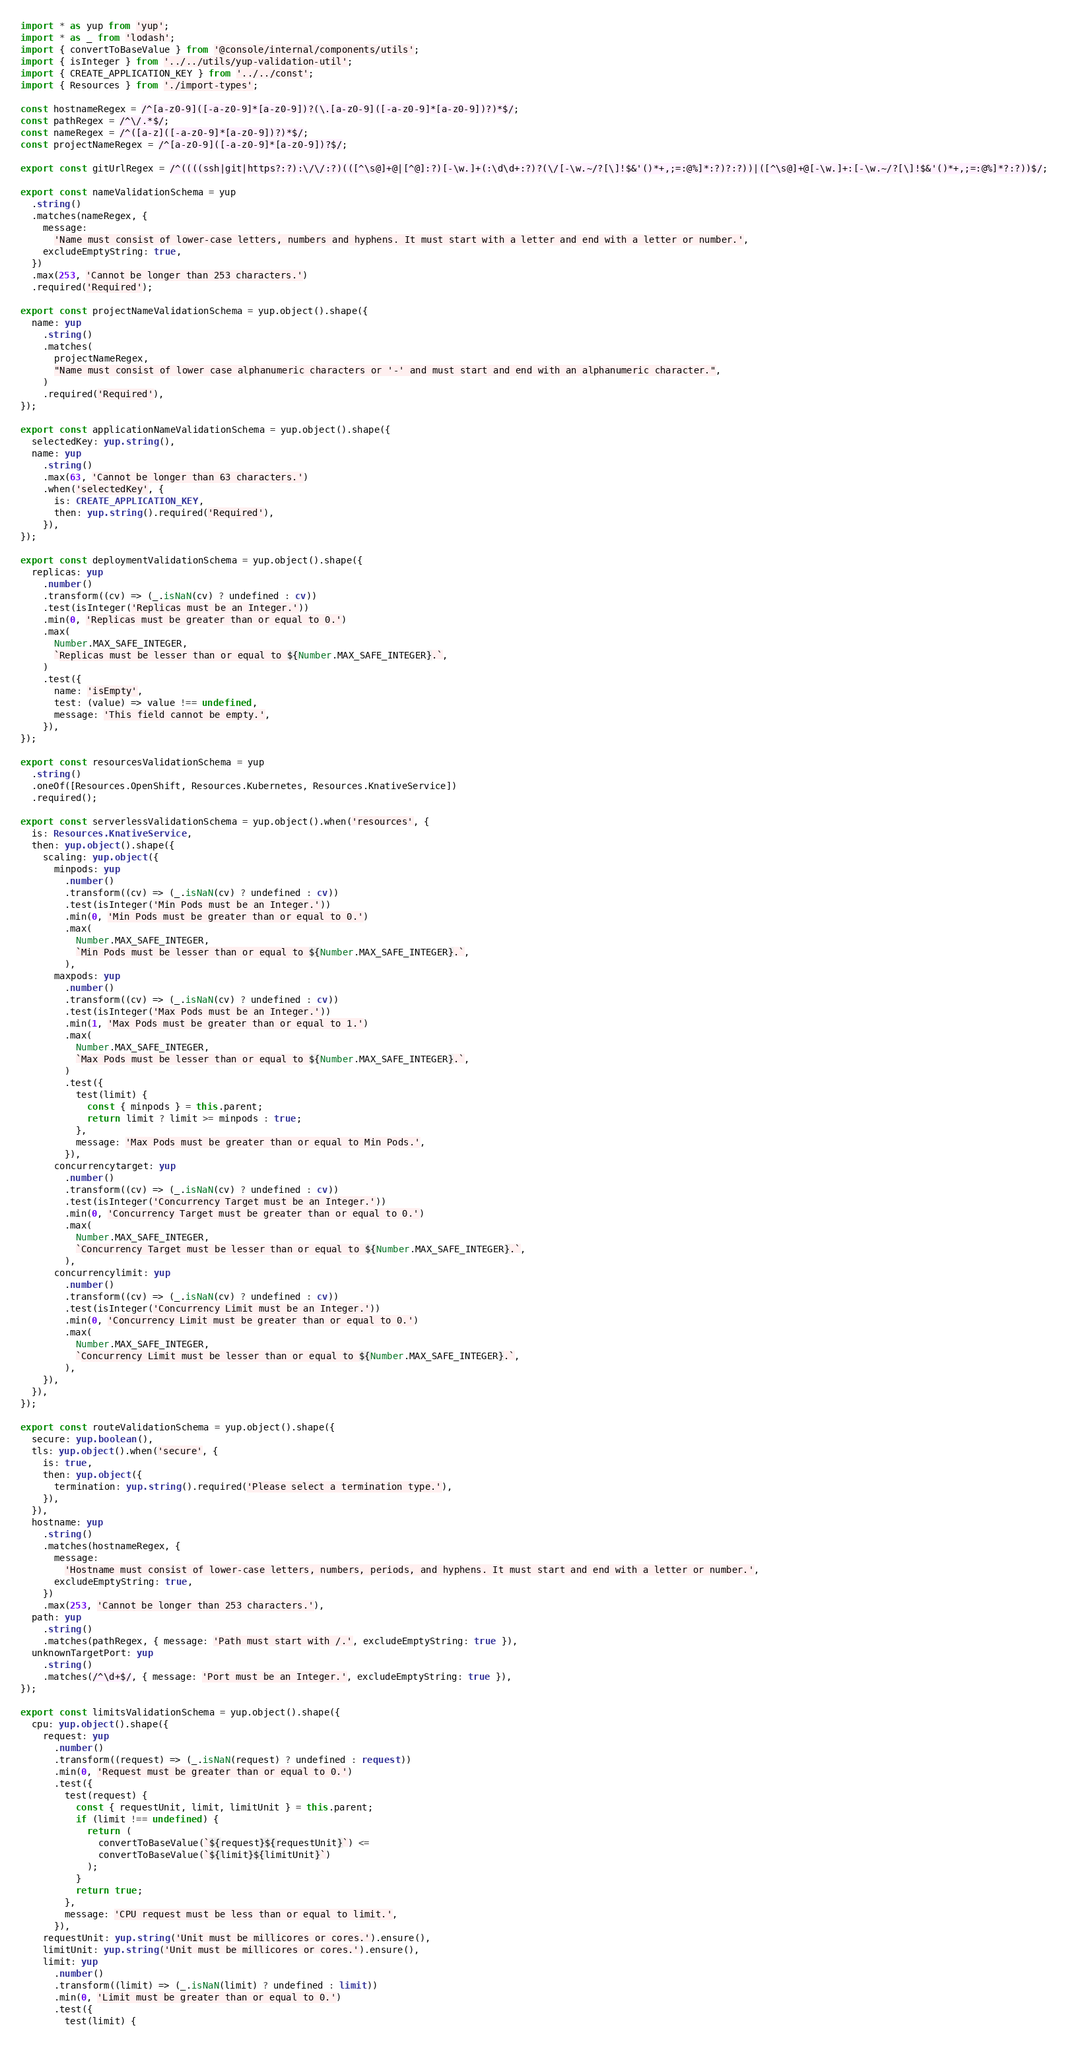<code> <loc_0><loc_0><loc_500><loc_500><_TypeScript_>import * as yup from 'yup';
import * as _ from 'lodash';
import { convertToBaseValue } from '@console/internal/components/utils';
import { isInteger } from '../../utils/yup-validation-util';
import { CREATE_APPLICATION_KEY } from '../../const';
import { Resources } from './import-types';

const hostnameRegex = /^[a-z0-9]([-a-z0-9]*[a-z0-9])?(\.[a-z0-9]([-a-z0-9]*[a-z0-9])?)*$/;
const pathRegex = /^\/.*$/;
const nameRegex = /^([a-z]([-a-z0-9]*[a-z0-9])?)*$/;
const projectNameRegex = /^[a-z0-9]([-a-z0-9]*[a-z0-9])?$/;

export const gitUrlRegex = /^((((ssh|git|https?:?):\/\/:?)(([^\s@]+@|[^@]:?)[-\w.]+(:\d\d+:?)?(\/[-\w.~/?[\]!$&'()*+,;=:@%]*:?)?:?))|([^\s@]+@[-\w.]+:[-\w.~/?[\]!$&'()*+,;=:@%]*?:?))$/;

export const nameValidationSchema = yup
  .string()
  .matches(nameRegex, {
    message:
      'Name must consist of lower-case letters, numbers and hyphens. It must start with a letter and end with a letter or number.',
    excludeEmptyString: true,
  })
  .max(253, 'Cannot be longer than 253 characters.')
  .required('Required');

export const projectNameValidationSchema = yup.object().shape({
  name: yup
    .string()
    .matches(
      projectNameRegex,
      "Name must consist of lower case alphanumeric characters or '-' and must start and end with an alphanumeric character.",
    )
    .required('Required'),
});

export const applicationNameValidationSchema = yup.object().shape({
  selectedKey: yup.string(),
  name: yup
    .string()
    .max(63, 'Cannot be longer than 63 characters.')
    .when('selectedKey', {
      is: CREATE_APPLICATION_KEY,
      then: yup.string().required('Required'),
    }),
});

export const deploymentValidationSchema = yup.object().shape({
  replicas: yup
    .number()
    .transform((cv) => (_.isNaN(cv) ? undefined : cv))
    .test(isInteger('Replicas must be an Integer.'))
    .min(0, 'Replicas must be greater than or equal to 0.')
    .max(
      Number.MAX_SAFE_INTEGER,
      `Replicas must be lesser than or equal to ${Number.MAX_SAFE_INTEGER}.`,
    )
    .test({
      name: 'isEmpty',
      test: (value) => value !== undefined,
      message: 'This field cannot be empty.',
    }),
});

export const resourcesValidationSchema = yup
  .string()
  .oneOf([Resources.OpenShift, Resources.Kubernetes, Resources.KnativeService])
  .required();

export const serverlessValidationSchema = yup.object().when('resources', {
  is: Resources.KnativeService,
  then: yup.object().shape({
    scaling: yup.object({
      minpods: yup
        .number()
        .transform((cv) => (_.isNaN(cv) ? undefined : cv))
        .test(isInteger('Min Pods must be an Integer.'))
        .min(0, 'Min Pods must be greater than or equal to 0.')
        .max(
          Number.MAX_SAFE_INTEGER,
          `Min Pods must be lesser than or equal to ${Number.MAX_SAFE_INTEGER}.`,
        ),
      maxpods: yup
        .number()
        .transform((cv) => (_.isNaN(cv) ? undefined : cv))
        .test(isInteger('Max Pods must be an Integer.'))
        .min(1, 'Max Pods must be greater than or equal to 1.')
        .max(
          Number.MAX_SAFE_INTEGER,
          `Max Pods must be lesser than or equal to ${Number.MAX_SAFE_INTEGER}.`,
        )
        .test({
          test(limit) {
            const { minpods } = this.parent;
            return limit ? limit >= minpods : true;
          },
          message: 'Max Pods must be greater than or equal to Min Pods.',
        }),
      concurrencytarget: yup
        .number()
        .transform((cv) => (_.isNaN(cv) ? undefined : cv))
        .test(isInteger('Concurrency Target must be an Integer.'))
        .min(0, 'Concurrency Target must be greater than or equal to 0.')
        .max(
          Number.MAX_SAFE_INTEGER,
          `Concurrency Target must be lesser than or equal to ${Number.MAX_SAFE_INTEGER}.`,
        ),
      concurrencylimit: yup
        .number()
        .transform((cv) => (_.isNaN(cv) ? undefined : cv))
        .test(isInteger('Concurrency Limit must be an Integer.'))
        .min(0, 'Concurrency Limit must be greater than or equal to 0.')
        .max(
          Number.MAX_SAFE_INTEGER,
          `Concurrency Limit must be lesser than or equal to ${Number.MAX_SAFE_INTEGER}.`,
        ),
    }),
  }),
});

export const routeValidationSchema = yup.object().shape({
  secure: yup.boolean(),
  tls: yup.object().when('secure', {
    is: true,
    then: yup.object({
      termination: yup.string().required('Please select a termination type.'),
    }),
  }),
  hostname: yup
    .string()
    .matches(hostnameRegex, {
      message:
        'Hostname must consist of lower-case letters, numbers, periods, and hyphens. It must start and end with a letter or number.',
      excludeEmptyString: true,
    })
    .max(253, 'Cannot be longer than 253 characters.'),
  path: yup
    .string()
    .matches(pathRegex, { message: 'Path must start with /.', excludeEmptyString: true }),
  unknownTargetPort: yup
    .string()
    .matches(/^\d+$/, { message: 'Port must be an Integer.', excludeEmptyString: true }),
});

export const limitsValidationSchema = yup.object().shape({
  cpu: yup.object().shape({
    request: yup
      .number()
      .transform((request) => (_.isNaN(request) ? undefined : request))
      .min(0, 'Request must be greater than or equal to 0.')
      .test({
        test(request) {
          const { requestUnit, limit, limitUnit } = this.parent;
          if (limit !== undefined) {
            return (
              convertToBaseValue(`${request}${requestUnit}`) <=
              convertToBaseValue(`${limit}${limitUnit}`)
            );
          }
          return true;
        },
        message: 'CPU request must be less than or equal to limit.',
      }),
    requestUnit: yup.string('Unit must be millicores or cores.').ensure(),
    limitUnit: yup.string('Unit must be millicores or cores.').ensure(),
    limit: yup
      .number()
      .transform((limit) => (_.isNaN(limit) ? undefined : limit))
      .min(0, 'Limit must be greater than or equal to 0.')
      .test({
        test(limit) {</code> 